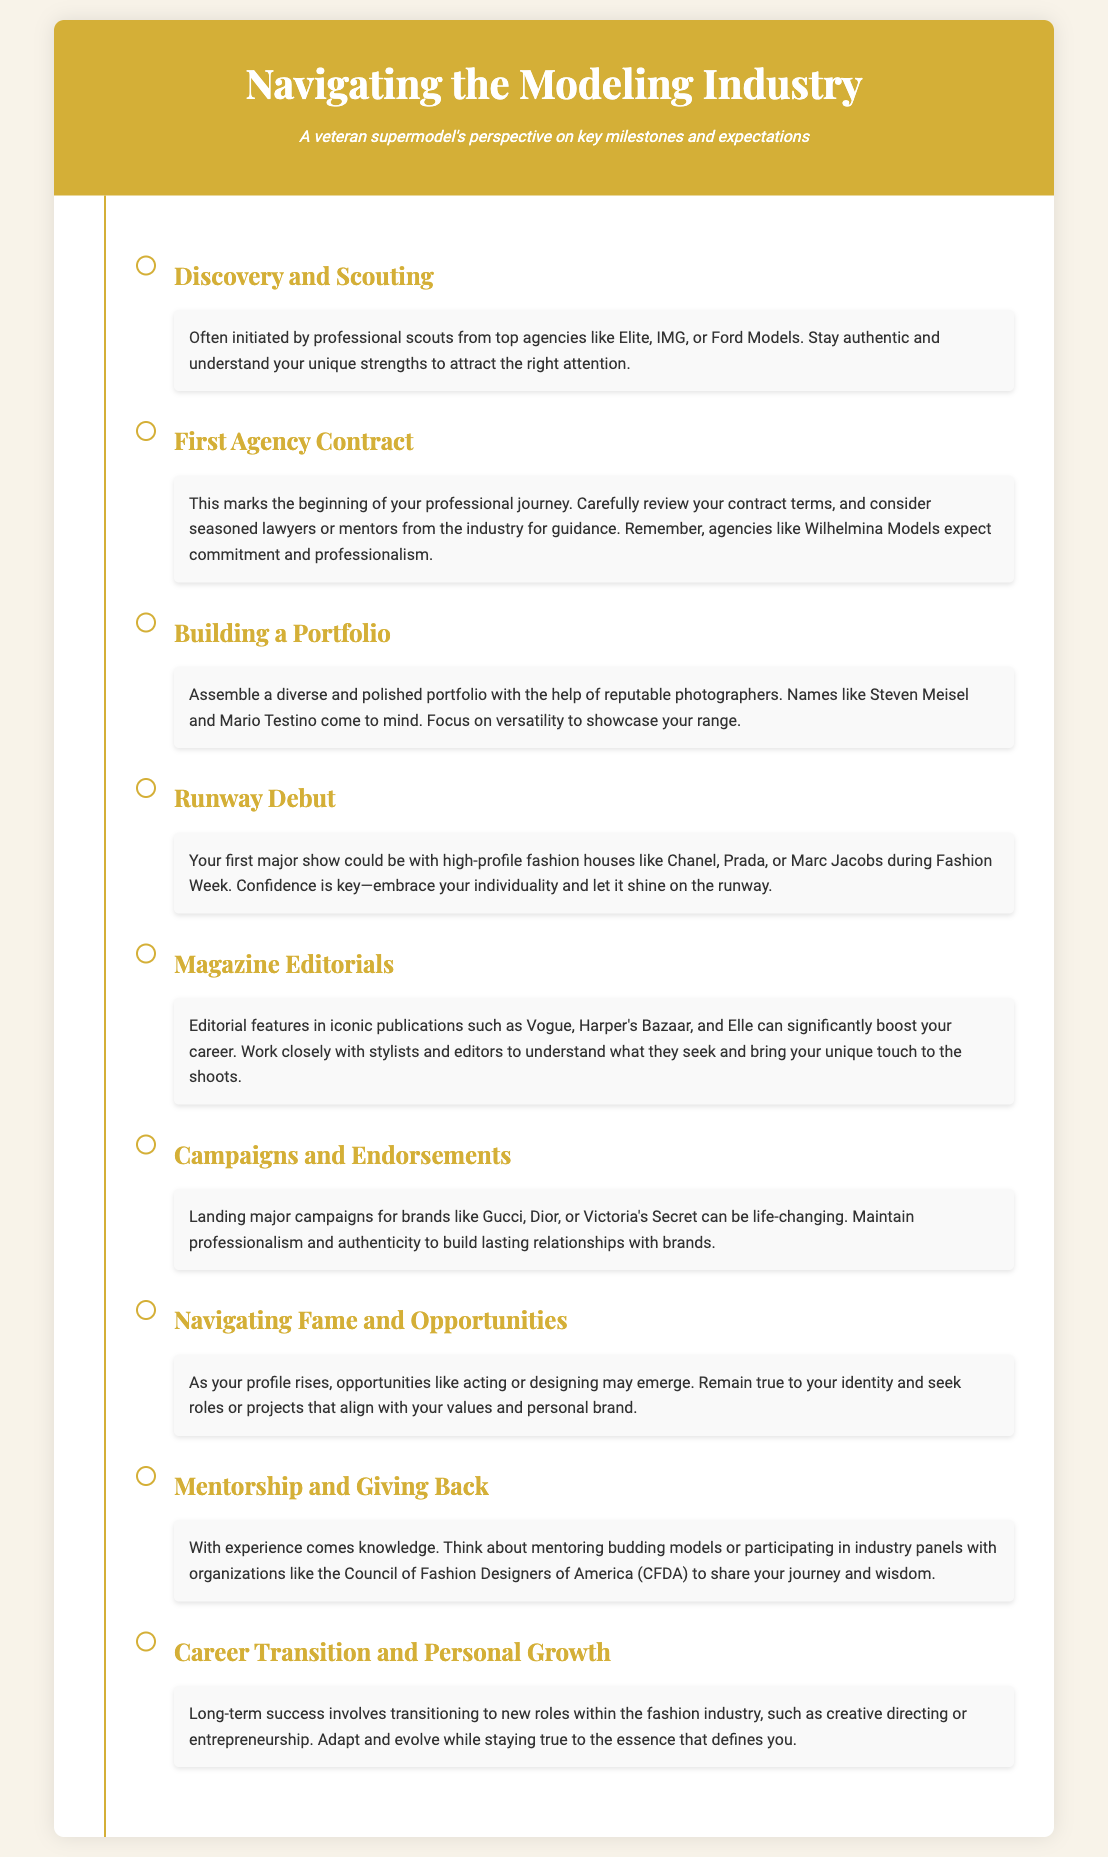What is the first milestone in the modeling industry? The first milestone is often initiated by professional scouts from top agencies.
Answer: Discovery and Scouting Which brands are mentioned for major campaigns? The brands listed for major campaigns include Gucci, Dior, and Victoria's Secret.
Answer: Gucci, Dior, Victoria's Secret What is crucial when reviewing your first agency contract? It is important to carefully review your contract terms.
Answer: Review contract terms Name one iconic publication where magazine editorials can be featured. One iconic publication mentioned is Vogue.
Answer: Vogue How does the document suggest aspiring models should approach their runway debut? The document suggests that confidence is key during the runway debut.
Answer: Confidence What role can models take on as they transition in their careers? Models can transition to new roles like creative directing or entrepreneurship.
Answer: Creative directing or entrepreneurship What is advised when working with stylists and editors? It is advised to understand what stylists and editors seek.
Answer: Understand their needs What aspect of personal development is addressed in the document? The document addresses career transition and personal growth.
Answer: Career transition and personal growth What should models consider before attending their first major show? Models should embrace their individuality and let it shine on the runway.
Answer: Embrace individuality 